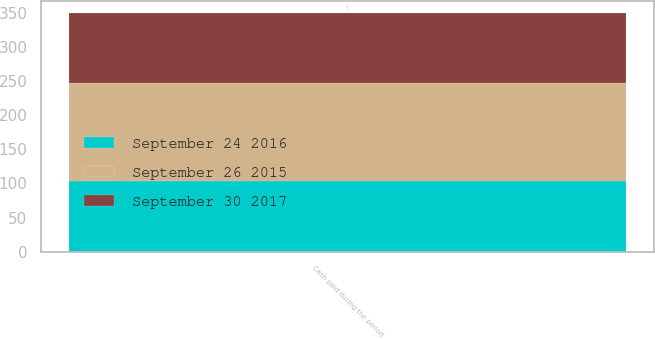Convert chart. <chart><loc_0><loc_0><loc_500><loc_500><stacked_bar_chart><ecel><fcel>Cash paid during the period<nl><fcel>September 30 2017<fcel>102.4<nl><fcel>September 24 2016<fcel>104<nl><fcel>September 26 2015<fcel>143<nl></chart> 